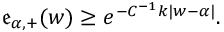Convert formula to latex. <formula><loc_0><loc_0><loc_500><loc_500>\begin{array} { r } { \mathfrak { e } _ { \alpha , + } ( w ) \geq e ^ { - C ^ { - 1 } k | w - \alpha | } . } \end{array}</formula> 